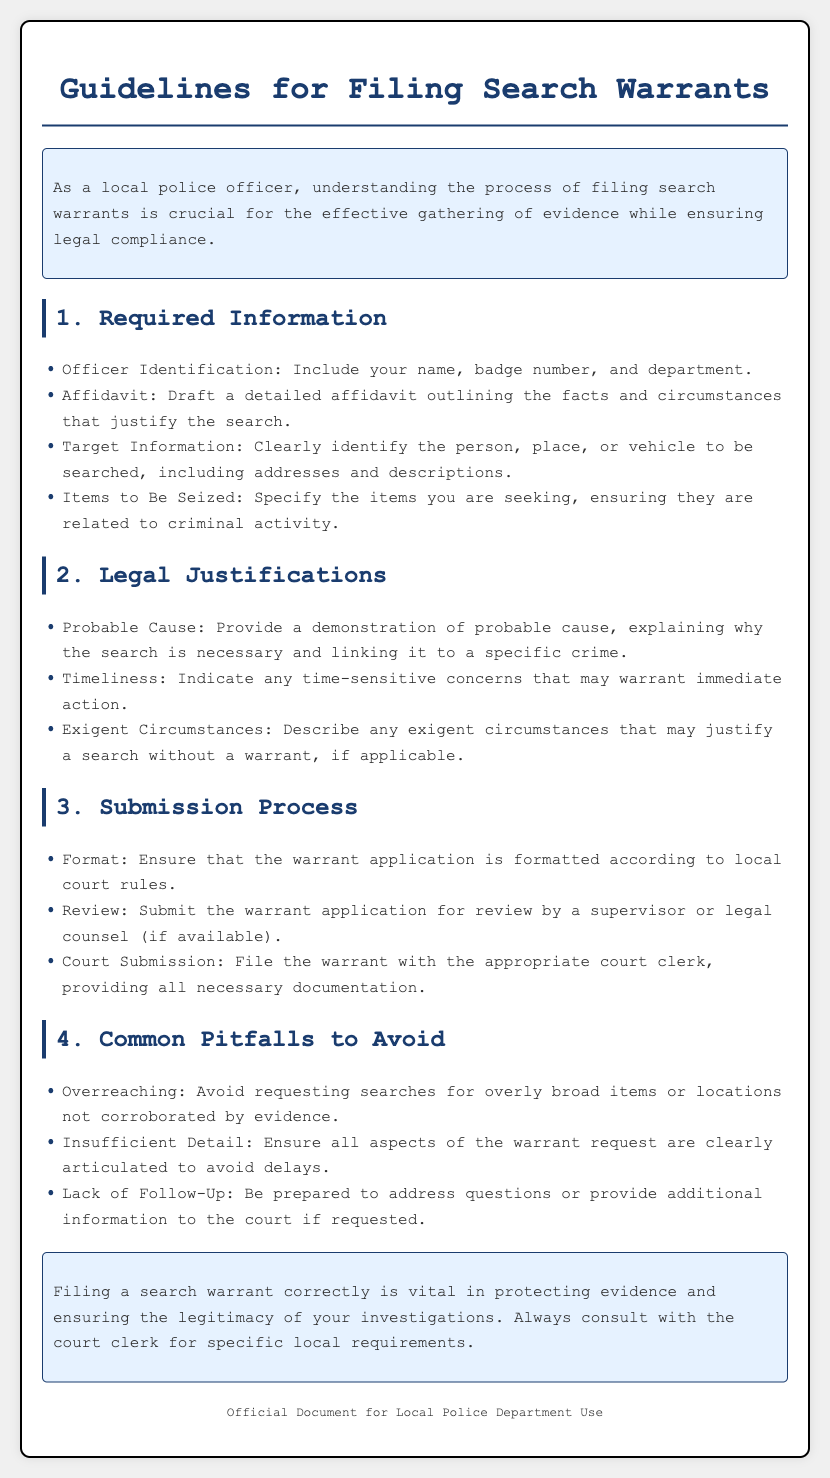what information must be included about the officer? The manual states to include the officer's name, badge number, and department.
Answer: name, badge number, and department what is the main legal justification for a search warrant? The document emphasizes the requirement to demonstrate probable cause linking the search to a specific crime.
Answer: probable cause how should the items to be seized be described? The items should be specified as being related to criminal activity.
Answer: related to criminal activity what are the common pitfalls to avoid when filing a search warrant? The manual lists pitfalls like overreaching and insufficient detail in the warrant request.
Answer: overreaching and insufficient detail how many sections are in the guidelines document? The document has a total of four sections detailing various aspects of filing search warrants.
Answer: four what is the purpose of the affidavit in the search warrant process? The affidavit is used to outline the facts and circumstances that justify the search.
Answer: outline the facts and circumstances what should be checked before submitting a warrant application? It should be reviewed by a supervisor or legal counsel, if available.
Answer: reviewed by a supervisor or legal counsel what might necessitate immediate action in filing a search warrant? The document mentions timeliness as a factor that may warrant immediate action.
Answer: timeliness 